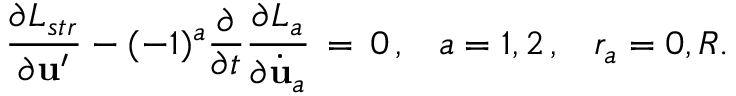Convert formula to latex. <formula><loc_0><loc_0><loc_500><loc_500>\frac { \partial L _ { s t r } } { \partial { u } ^ { \prime } } - ( - 1 ) ^ { a } \frac { \partial } { \partial t } \frac { \partial L _ { a } } { \partial \dot { u } _ { a } } \, = \, 0 \, { , } \quad a = 1 , 2 \, { , } \quad r _ { a } = 0 , R .</formula> 